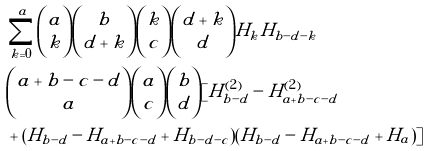<formula> <loc_0><loc_0><loc_500><loc_500>& \sum _ { k = 0 } ^ { a } \binom { a } { k } \binom { b } { d + k } \binom { k } { c } \binom { d + k } { d } H _ { k } H _ { b - d - k } \\ & \binom { a + b - c - d } { a } \binom { a } { c } \binom { b } { d } [ H _ { b - d } ^ { ( 2 ) } - H _ { a + b - c - d } ^ { ( 2 ) } \\ & + ( H _ { b - d } - H _ { a + b - c - d } + H _ { b - d - c } ) ( H _ { b - d } - H _ { a + b - c - d } + H _ { a } ) ]</formula> 